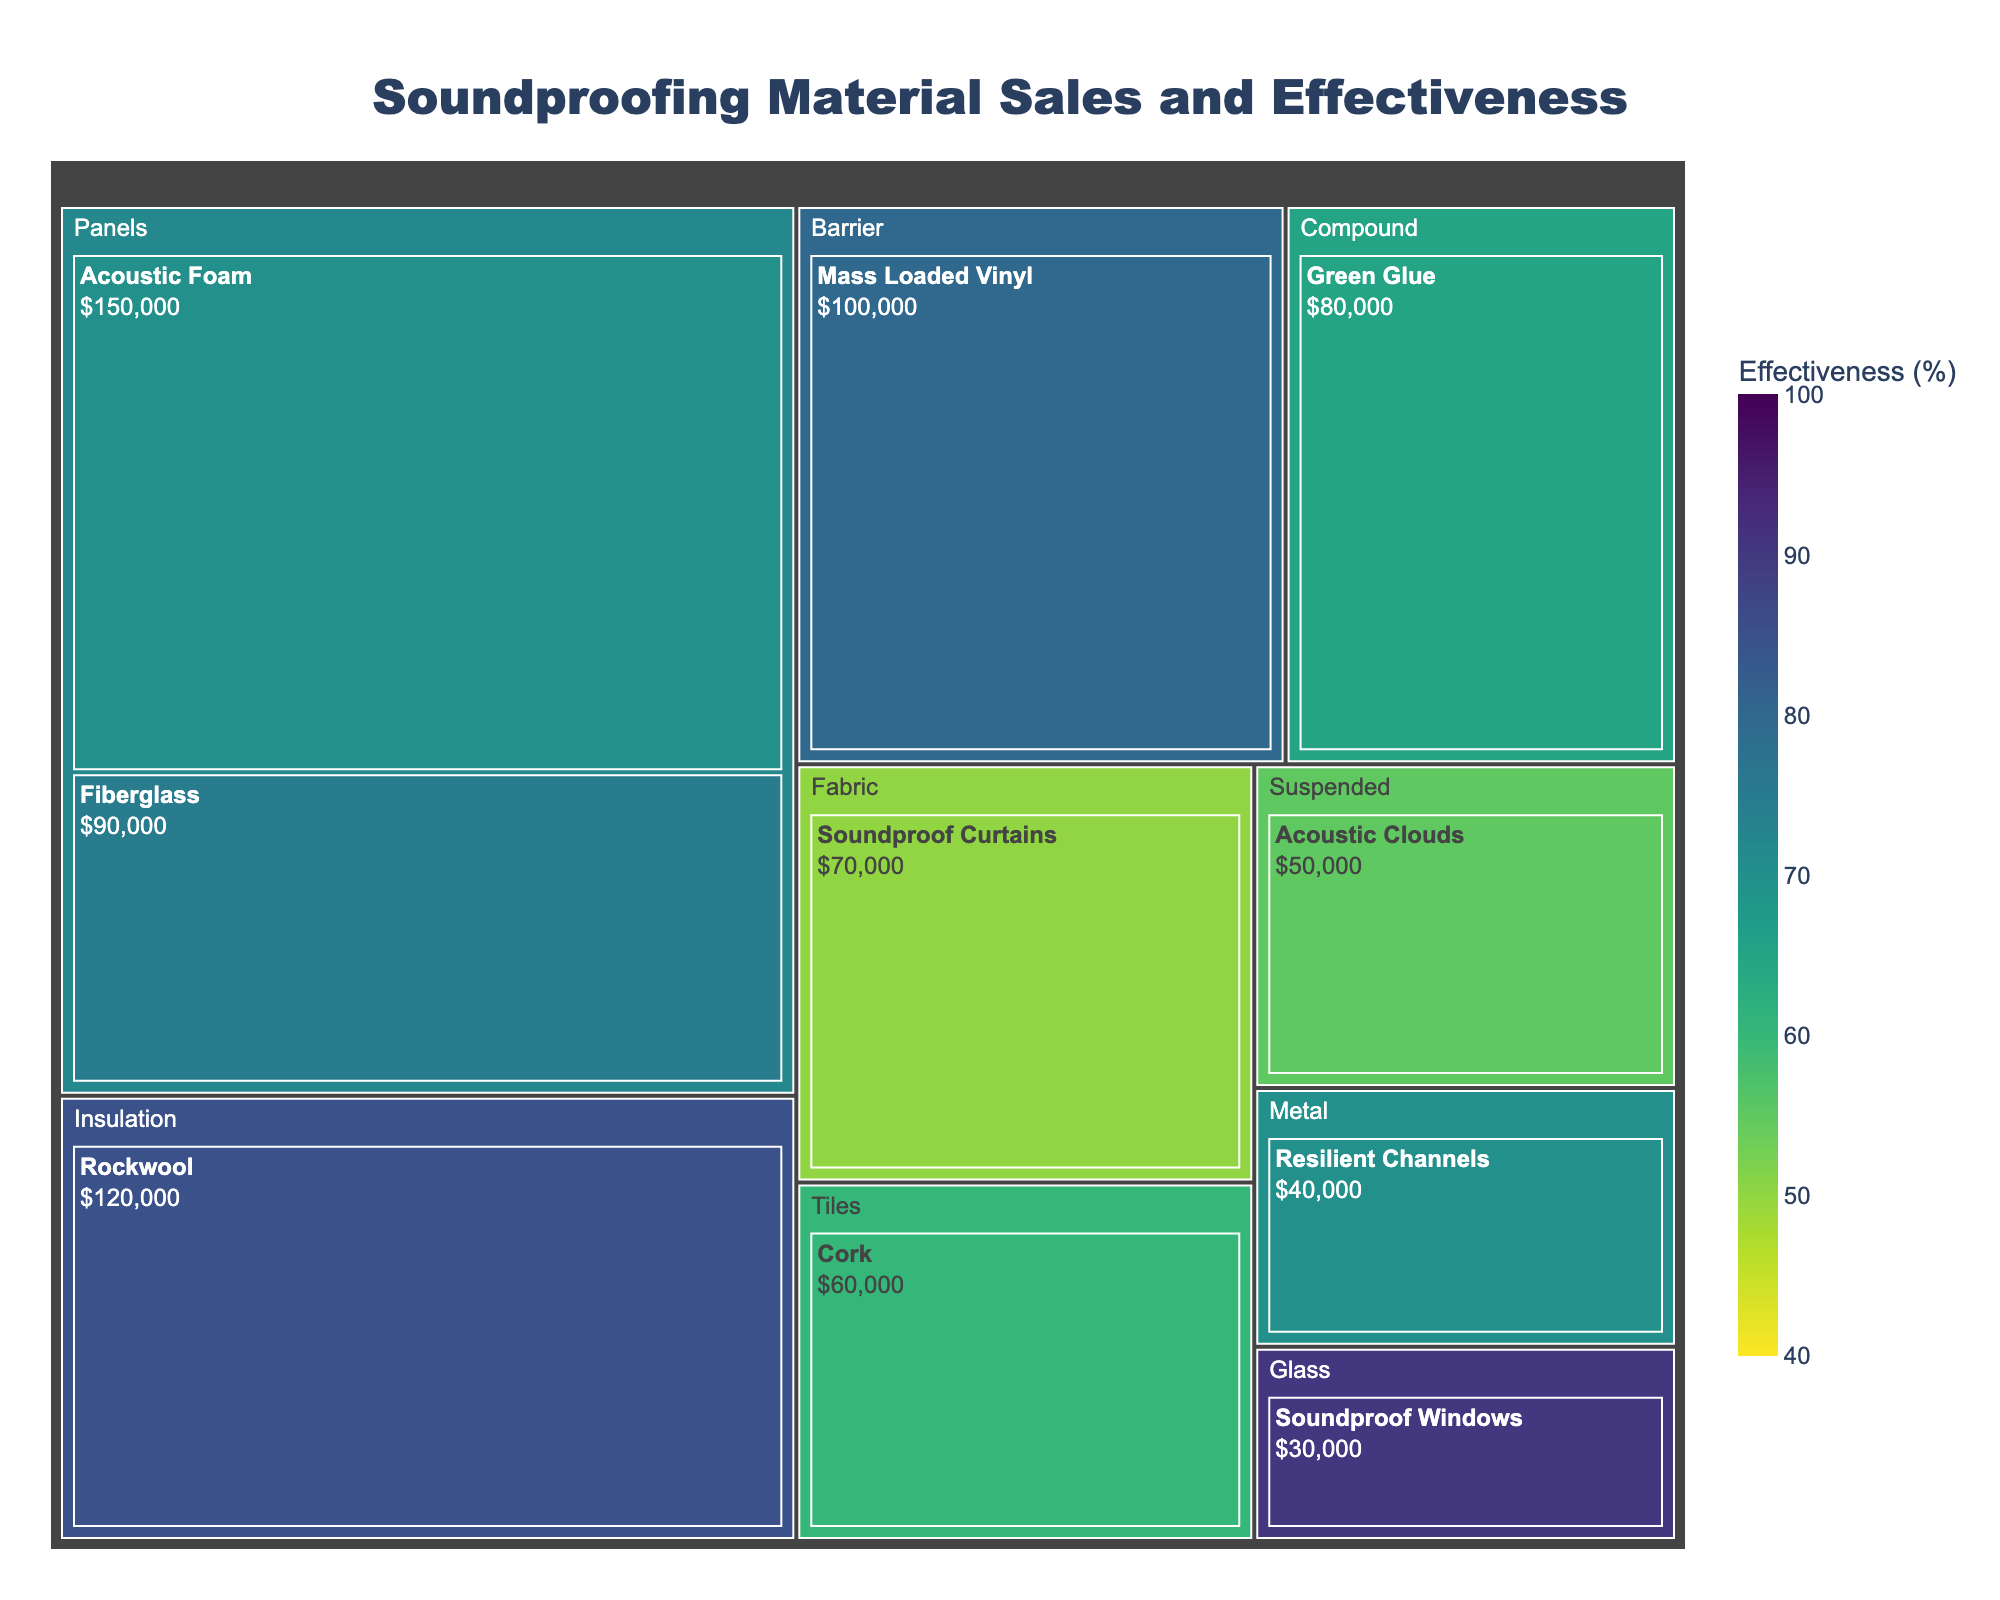Which material has the highest sales? The material with the highest sales is represented by the largest area in the treemap. By examining the figure, Acoustic Foam has the largest area.
Answer: Acoustic Foam What is the effectiveness of the Rockwool material? To find the effectiveness of Rockwool, look at the color bar and the color of the Rockwool section. Rockwool is colored to match an effectiveness of 85%.
Answer: 85% Which material type includes the Soundproof Windows? By looking at the hierarchical structure of the treemap, Soundproof Windows can be found under the "Glass" type.
Answer: Glass Rank the materials by sales from highest to lowest. To rank the materials by sales, examine their area sizes and labels: Acoustic Foam ($150,000), Rockwool ($120,000), Mass Loaded Vinyl ($100,000), Fiberglass ($90,000), Green Glue ($80,000), Soundproof Curtains ($70,000), Cork ($60,000), Acoustic Clouds ($50,000), Resilient Channels ($40,000), Soundproof Windows ($30,000).
Answer: Acoustic Foam > Rockwool > Mass Loaded Vinyl > Fiberglass > Green Glue > Soundproof Curtains > Cork > Acoustic Clouds > Resilient Channels > Soundproof Windows Which type has the highest average effectiveness? Calculate the average effectiveness by summing up the effectiveness of materials within each type and dividing by the number of materials in that type. The "Glass" type with Soundproof Windows has the highest effectiveness of 90%.
Answer: Glass Which material has the lowest effectiveness and what is its value? To find the material with the lowest effectiveness, look for the lightest color on the color axis. Soundproof Curtains show the lowest effectiveness at 50%.
Answer: Soundproof Curtains, 50% What is the combined sales value of Resilient Channels and Soundproof Windows? Add the sales values of Resilient Channels and Soundproof Windows from their segments: $40,000 + $30,000 = $70,000.
Answer: $70,000 Which material in the "Panels" type has the higher effectiveness? Compare the effectiveness values of materials in the "Panels" type, Acoustic Foam (70%) and Fiberglass (75%). Fiberglass has a higher effectiveness.
Answer: Fiberglass Identify the material with the smallest sales value and its corresponding effectiveness. The material with the smallest area on the treemap is Soundproof Windows with $30,000 in sales. Its color indicates an effectiveness of 90%.
Answer: Soundproof Windows, 90% What is the most expensive material in the "Compound" type? The "Compound" type only contains Green Glue, making it the most and only expensive material in this category with $80,000 in sales.
Answer: Green Glue 